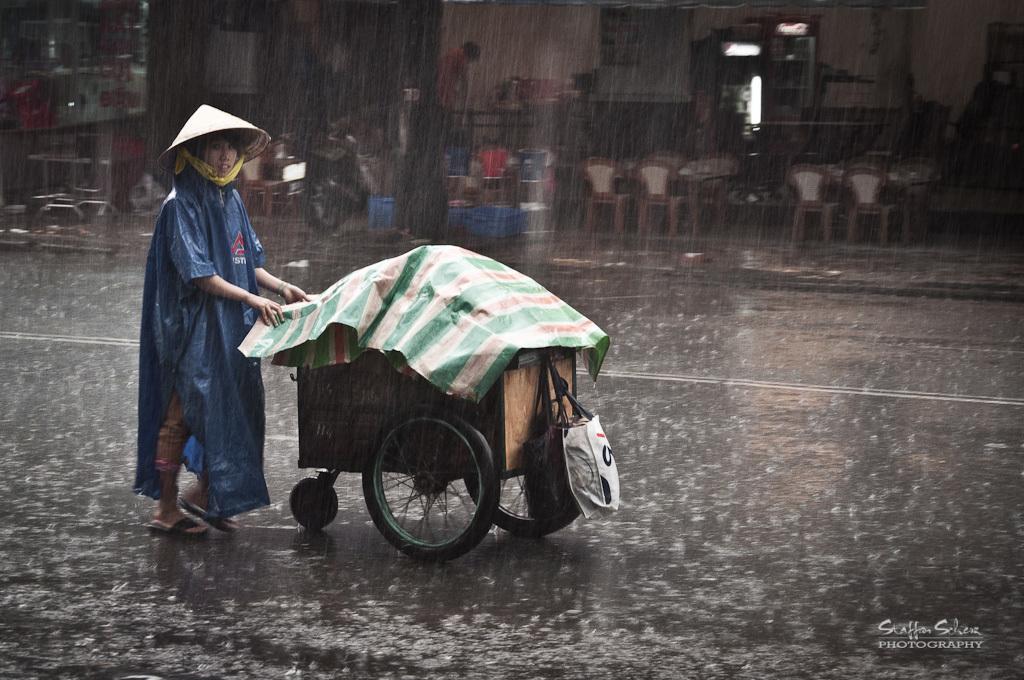Describe this image in one or two sentences. In the image there is a person with a hat on the head is walking. She is holding the stroller in the hand. On the stroller there is a cover and also there is a bag. In the background there is a footpath with chairs, tables, bike and some other items. And also there is a building with wall. And it is raining in the picture. In the bottom right corner of the image there is a name. 